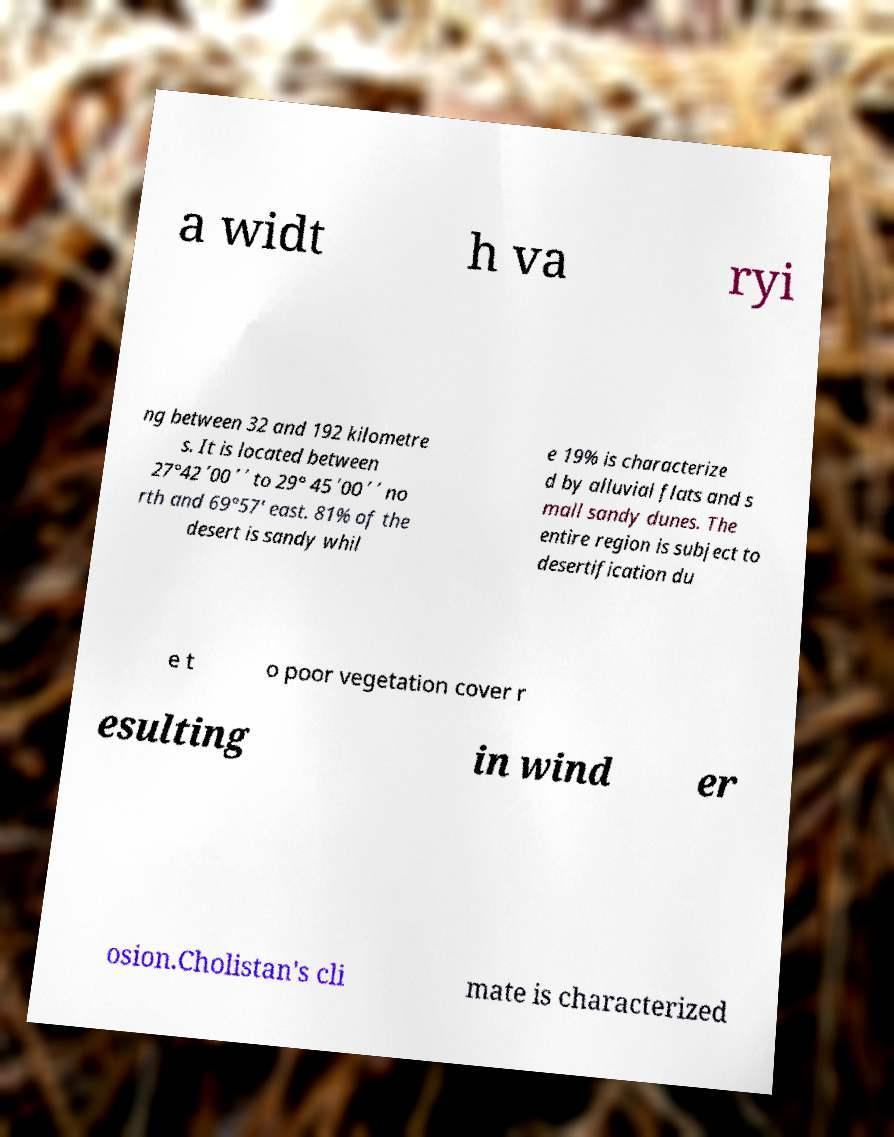Can you read and provide the text displayed in the image?This photo seems to have some interesting text. Can you extract and type it out for me? a widt h va ryi ng between 32 and 192 kilometre s. It is located between 27°42΄00΄΄ to 29° 45΄00΄΄ no rth and 69°57′ east. 81% of the desert is sandy whil e 19% is characterize d by alluvial flats and s mall sandy dunes. The entire region is subject to desertification du e t o poor vegetation cover r esulting in wind er osion.Cholistan's cli mate is characterized 